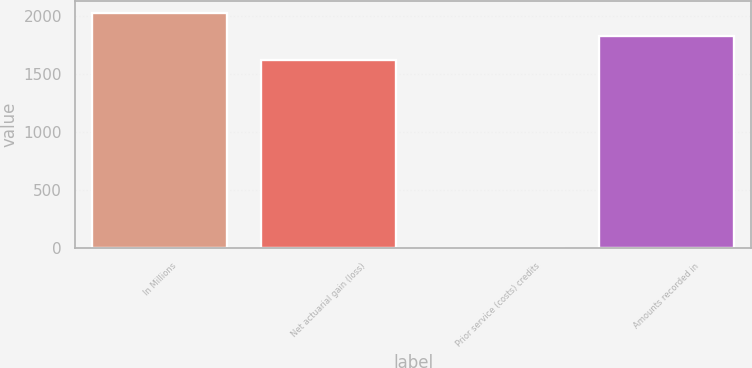<chart> <loc_0><loc_0><loc_500><loc_500><bar_chart><fcel>In Millions<fcel>Net actuarial gain (loss)<fcel>Prior service (costs) credits<fcel>Amounts recorded in<nl><fcel>2024.02<fcel>1621.4<fcel>3.9<fcel>1822.71<nl></chart> 